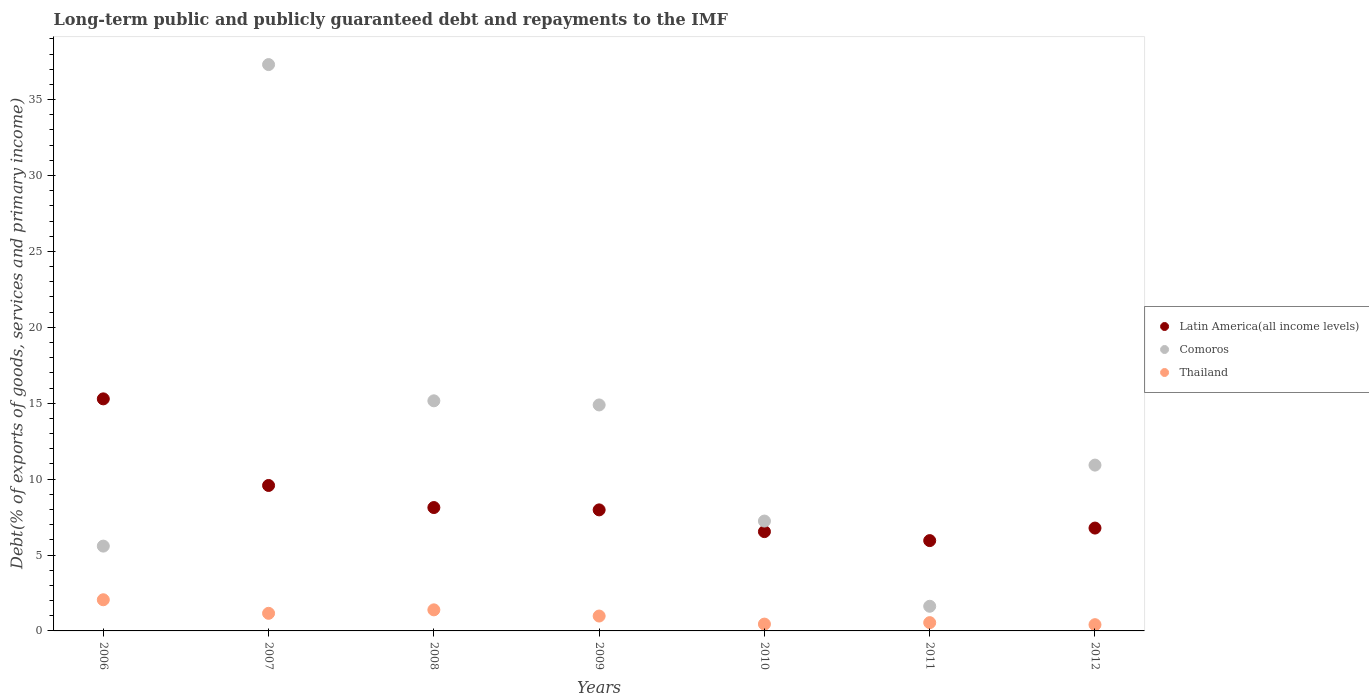How many different coloured dotlines are there?
Ensure brevity in your answer.  3. What is the debt and repayments in Thailand in 2012?
Offer a terse response. 0.41. Across all years, what is the maximum debt and repayments in Thailand?
Provide a short and direct response. 2.05. Across all years, what is the minimum debt and repayments in Thailand?
Your answer should be compact. 0.41. In which year was the debt and repayments in Latin America(all income levels) maximum?
Provide a succinct answer. 2006. What is the total debt and repayments in Comoros in the graph?
Provide a succinct answer. 92.73. What is the difference between the debt and repayments in Thailand in 2009 and that in 2010?
Provide a short and direct response. 0.53. What is the difference between the debt and repayments in Comoros in 2006 and the debt and repayments in Latin America(all income levels) in 2008?
Offer a terse response. -2.54. What is the average debt and repayments in Latin America(all income levels) per year?
Offer a terse response. 8.61. In the year 2009, what is the difference between the debt and repayments in Comoros and debt and repayments in Thailand?
Your answer should be compact. 13.91. What is the ratio of the debt and repayments in Comoros in 2006 to that in 2009?
Provide a short and direct response. 0.38. Is the debt and repayments in Comoros in 2010 less than that in 2011?
Your response must be concise. No. What is the difference between the highest and the second highest debt and repayments in Latin America(all income levels)?
Give a very brief answer. 5.71. What is the difference between the highest and the lowest debt and repayments in Comoros?
Keep it short and to the point. 35.68. In how many years, is the debt and repayments in Thailand greater than the average debt and repayments in Thailand taken over all years?
Keep it short and to the point. 3. Does the debt and repayments in Latin America(all income levels) monotonically increase over the years?
Make the answer very short. No. Is the debt and repayments in Comoros strictly less than the debt and repayments in Thailand over the years?
Provide a short and direct response. No. Does the graph contain any zero values?
Make the answer very short. No. Does the graph contain grids?
Your answer should be compact. No. How many legend labels are there?
Offer a terse response. 3. What is the title of the graph?
Your answer should be compact. Long-term public and publicly guaranteed debt and repayments to the IMF. Does "Other small states" appear as one of the legend labels in the graph?
Your response must be concise. No. What is the label or title of the Y-axis?
Keep it short and to the point. Debt(% of exports of goods, services and primary income). What is the Debt(% of exports of goods, services and primary income) in Latin America(all income levels) in 2006?
Give a very brief answer. 15.29. What is the Debt(% of exports of goods, services and primary income) of Comoros in 2006?
Keep it short and to the point. 5.59. What is the Debt(% of exports of goods, services and primary income) of Thailand in 2006?
Give a very brief answer. 2.05. What is the Debt(% of exports of goods, services and primary income) of Latin America(all income levels) in 2007?
Your answer should be very brief. 9.58. What is the Debt(% of exports of goods, services and primary income) of Comoros in 2007?
Offer a terse response. 37.31. What is the Debt(% of exports of goods, services and primary income) of Thailand in 2007?
Offer a terse response. 1.16. What is the Debt(% of exports of goods, services and primary income) in Latin America(all income levels) in 2008?
Your response must be concise. 8.13. What is the Debt(% of exports of goods, services and primary income) of Comoros in 2008?
Ensure brevity in your answer.  15.16. What is the Debt(% of exports of goods, services and primary income) of Thailand in 2008?
Provide a succinct answer. 1.39. What is the Debt(% of exports of goods, services and primary income) of Latin America(all income levels) in 2009?
Your answer should be very brief. 7.97. What is the Debt(% of exports of goods, services and primary income) of Comoros in 2009?
Keep it short and to the point. 14.89. What is the Debt(% of exports of goods, services and primary income) in Thailand in 2009?
Provide a short and direct response. 0.98. What is the Debt(% of exports of goods, services and primary income) of Latin America(all income levels) in 2010?
Your answer should be very brief. 6.54. What is the Debt(% of exports of goods, services and primary income) in Comoros in 2010?
Give a very brief answer. 7.24. What is the Debt(% of exports of goods, services and primary income) in Thailand in 2010?
Keep it short and to the point. 0.45. What is the Debt(% of exports of goods, services and primary income) in Latin America(all income levels) in 2011?
Your answer should be very brief. 5.95. What is the Debt(% of exports of goods, services and primary income) in Comoros in 2011?
Your response must be concise. 1.62. What is the Debt(% of exports of goods, services and primary income) of Thailand in 2011?
Your answer should be very brief. 0.55. What is the Debt(% of exports of goods, services and primary income) in Latin America(all income levels) in 2012?
Ensure brevity in your answer.  6.78. What is the Debt(% of exports of goods, services and primary income) in Comoros in 2012?
Keep it short and to the point. 10.92. What is the Debt(% of exports of goods, services and primary income) in Thailand in 2012?
Give a very brief answer. 0.41. Across all years, what is the maximum Debt(% of exports of goods, services and primary income) of Latin America(all income levels)?
Make the answer very short. 15.29. Across all years, what is the maximum Debt(% of exports of goods, services and primary income) of Comoros?
Provide a succinct answer. 37.31. Across all years, what is the maximum Debt(% of exports of goods, services and primary income) in Thailand?
Your answer should be compact. 2.05. Across all years, what is the minimum Debt(% of exports of goods, services and primary income) in Latin America(all income levels)?
Ensure brevity in your answer.  5.95. Across all years, what is the minimum Debt(% of exports of goods, services and primary income) of Comoros?
Your answer should be very brief. 1.62. Across all years, what is the minimum Debt(% of exports of goods, services and primary income) of Thailand?
Your answer should be very brief. 0.41. What is the total Debt(% of exports of goods, services and primary income) in Latin America(all income levels) in the graph?
Make the answer very short. 60.24. What is the total Debt(% of exports of goods, services and primary income) in Comoros in the graph?
Ensure brevity in your answer.  92.73. What is the total Debt(% of exports of goods, services and primary income) in Thailand in the graph?
Make the answer very short. 6.99. What is the difference between the Debt(% of exports of goods, services and primary income) in Latin America(all income levels) in 2006 and that in 2007?
Keep it short and to the point. 5.71. What is the difference between the Debt(% of exports of goods, services and primary income) of Comoros in 2006 and that in 2007?
Your response must be concise. -31.72. What is the difference between the Debt(% of exports of goods, services and primary income) in Thailand in 2006 and that in 2007?
Keep it short and to the point. 0.89. What is the difference between the Debt(% of exports of goods, services and primary income) of Latin America(all income levels) in 2006 and that in 2008?
Offer a terse response. 7.16. What is the difference between the Debt(% of exports of goods, services and primary income) of Comoros in 2006 and that in 2008?
Keep it short and to the point. -9.57. What is the difference between the Debt(% of exports of goods, services and primary income) of Thailand in 2006 and that in 2008?
Ensure brevity in your answer.  0.66. What is the difference between the Debt(% of exports of goods, services and primary income) of Latin America(all income levels) in 2006 and that in 2009?
Provide a short and direct response. 7.31. What is the difference between the Debt(% of exports of goods, services and primary income) of Comoros in 2006 and that in 2009?
Ensure brevity in your answer.  -9.3. What is the difference between the Debt(% of exports of goods, services and primary income) of Thailand in 2006 and that in 2009?
Your response must be concise. 1.07. What is the difference between the Debt(% of exports of goods, services and primary income) of Latin America(all income levels) in 2006 and that in 2010?
Give a very brief answer. 8.75. What is the difference between the Debt(% of exports of goods, services and primary income) of Comoros in 2006 and that in 2010?
Provide a short and direct response. -1.65. What is the difference between the Debt(% of exports of goods, services and primary income) in Thailand in 2006 and that in 2010?
Your response must be concise. 1.6. What is the difference between the Debt(% of exports of goods, services and primary income) of Latin America(all income levels) in 2006 and that in 2011?
Offer a very short reply. 9.34. What is the difference between the Debt(% of exports of goods, services and primary income) of Comoros in 2006 and that in 2011?
Give a very brief answer. 3.96. What is the difference between the Debt(% of exports of goods, services and primary income) of Thailand in 2006 and that in 2011?
Your response must be concise. 1.51. What is the difference between the Debt(% of exports of goods, services and primary income) in Latin America(all income levels) in 2006 and that in 2012?
Offer a very short reply. 8.51. What is the difference between the Debt(% of exports of goods, services and primary income) of Comoros in 2006 and that in 2012?
Your response must be concise. -5.34. What is the difference between the Debt(% of exports of goods, services and primary income) in Thailand in 2006 and that in 2012?
Provide a short and direct response. 1.64. What is the difference between the Debt(% of exports of goods, services and primary income) of Latin America(all income levels) in 2007 and that in 2008?
Your response must be concise. 1.45. What is the difference between the Debt(% of exports of goods, services and primary income) of Comoros in 2007 and that in 2008?
Your answer should be compact. 22.15. What is the difference between the Debt(% of exports of goods, services and primary income) of Thailand in 2007 and that in 2008?
Your answer should be very brief. -0.23. What is the difference between the Debt(% of exports of goods, services and primary income) in Latin America(all income levels) in 2007 and that in 2009?
Provide a short and direct response. 1.61. What is the difference between the Debt(% of exports of goods, services and primary income) in Comoros in 2007 and that in 2009?
Provide a short and direct response. 22.42. What is the difference between the Debt(% of exports of goods, services and primary income) in Thailand in 2007 and that in 2009?
Ensure brevity in your answer.  0.18. What is the difference between the Debt(% of exports of goods, services and primary income) of Latin America(all income levels) in 2007 and that in 2010?
Offer a very short reply. 3.04. What is the difference between the Debt(% of exports of goods, services and primary income) of Comoros in 2007 and that in 2010?
Make the answer very short. 30.07. What is the difference between the Debt(% of exports of goods, services and primary income) of Thailand in 2007 and that in 2010?
Your answer should be compact. 0.71. What is the difference between the Debt(% of exports of goods, services and primary income) of Latin America(all income levels) in 2007 and that in 2011?
Keep it short and to the point. 3.63. What is the difference between the Debt(% of exports of goods, services and primary income) of Comoros in 2007 and that in 2011?
Your answer should be very brief. 35.68. What is the difference between the Debt(% of exports of goods, services and primary income) of Thailand in 2007 and that in 2011?
Give a very brief answer. 0.61. What is the difference between the Debt(% of exports of goods, services and primary income) in Latin America(all income levels) in 2007 and that in 2012?
Provide a succinct answer. 2.81. What is the difference between the Debt(% of exports of goods, services and primary income) in Comoros in 2007 and that in 2012?
Give a very brief answer. 26.39. What is the difference between the Debt(% of exports of goods, services and primary income) of Thailand in 2007 and that in 2012?
Ensure brevity in your answer.  0.75. What is the difference between the Debt(% of exports of goods, services and primary income) in Latin America(all income levels) in 2008 and that in 2009?
Your answer should be very brief. 0.15. What is the difference between the Debt(% of exports of goods, services and primary income) in Comoros in 2008 and that in 2009?
Keep it short and to the point. 0.27. What is the difference between the Debt(% of exports of goods, services and primary income) in Thailand in 2008 and that in 2009?
Your response must be concise. 0.41. What is the difference between the Debt(% of exports of goods, services and primary income) of Latin America(all income levels) in 2008 and that in 2010?
Ensure brevity in your answer.  1.59. What is the difference between the Debt(% of exports of goods, services and primary income) in Comoros in 2008 and that in 2010?
Give a very brief answer. 7.92. What is the difference between the Debt(% of exports of goods, services and primary income) of Thailand in 2008 and that in 2010?
Offer a terse response. 0.94. What is the difference between the Debt(% of exports of goods, services and primary income) in Latin America(all income levels) in 2008 and that in 2011?
Offer a very short reply. 2.18. What is the difference between the Debt(% of exports of goods, services and primary income) in Comoros in 2008 and that in 2011?
Your response must be concise. 13.53. What is the difference between the Debt(% of exports of goods, services and primary income) of Thailand in 2008 and that in 2011?
Your answer should be compact. 0.84. What is the difference between the Debt(% of exports of goods, services and primary income) of Latin America(all income levels) in 2008 and that in 2012?
Your answer should be very brief. 1.35. What is the difference between the Debt(% of exports of goods, services and primary income) in Comoros in 2008 and that in 2012?
Your answer should be very brief. 4.24. What is the difference between the Debt(% of exports of goods, services and primary income) in Thailand in 2008 and that in 2012?
Give a very brief answer. 0.98. What is the difference between the Debt(% of exports of goods, services and primary income) in Latin America(all income levels) in 2009 and that in 2010?
Make the answer very short. 1.43. What is the difference between the Debt(% of exports of goods, services and primary income) of Comoros in 2009 and that in 2010?
Your response must be concise. 7.65. What is the difference between the Debt(% of exports of goods, services and primary income) in Thailand in 2009 and that in 2010?
Your response must be concise. 0.53. What is the difference between the Debt(% of exports of goods, services and primary income) of Latin America(all income levels) in 2009 and that in 2011?
Your response must be concise. 2.02. What is the difference between the Debt(% of exports of goods, services and primary income) of Comoros in 2009 and that in 2011?
Provide a succinct answer. 13.26. What is the difference between the Debt(% of exports of goods, services and primary income) of Thailand in 2009 and that in 2011?
Make the answer very short. 0.43. What is the difference between the Debt(% of exports of goods, services and primary income) in Latin America(all income levels) in 2009 and that in 2012?
Provide a short and direct response. 1.2. What is the difference between the Debt(% of exports of goods, services and primary income) in Comoros in 2009 and that in 2012?
Offer a terse response. 3.96. What is the difference between the Debt(% of exports of goods, services and primary income) of Thailand in 2009 and that in 2012?
Your answer should be very brief. 0.57. What is the difference between the Debt(% of exports of goods, services and primary income) in Latin America(all income levels) in 2010 and that in 2011?
Provide a succinct answer. 0.59. What is the difference between the Debt(% of exports of goods, services and primary income) of Comoros in 2010 and that in 2011?
Offer a very short reply. 5.61. What is the difference between the Debt(% of exports of goods, services and primary income) in Thailand in 2010 and that in 2011?
Your answer should be compact. -0.1. What is the difference between the Debt(% of exports of goods, services and primary income) of Latin America(all income levels) in 2010 and that in 2012?
Make the answer very short. -0.23. What is the difference between the Debt(% of exports of goods, services and primary income) in Comoros in 2010 and that in 2012?
Provide a succinct answer. -3.69. What is the difference between the Debt(% of exports of goods, services and primary income) of Thailand in 2010 and that in 2012?
Your answer should be compact. 0.04. What is the difference between the Debt(% of exports of goods, services and primary income) in Latin America(all income levels) in 2011 and that in 2012?
Your answer should be very brief. -0.83. What is the difference between the Debt(% of exports of goods, services and primary income) in Comoros in 2011 and that in 2012?
Your response must be concise. -9.3. What is the difference between the Debt(% of exports of goods, services and primary income) of Thailand in 2011 and that in 2012?
Provide a succinct answer. 0.13. What is the difference between the Debt(% of exports of goods, services and primary income) of Latin America(all income levels) in 2006 and the Debt(% of exports of goods, services and primary income) of Comoros in 2007?
Your answer should be compact. -22.02. What is the difference between the Debt(% of exports of goods, services and primary income) of Latin America(all income levels) in 2006 and the Debt(% of exports of goods, services and primary income) of Thailand in 2007?
Offer a very short reply. 14.13. What is the difference between the Debt(% of exports of goods, services and primary income) of Comoros in 2006 and the Debt(% of exports of goods, services and primary income) of Thailand in 2007?
Offer a terse response. 4.43. What is the difference between the Debt(% of exports of goods, services and primary income) in Latin America(all income levels) in 2006 and the Debt(% of exports of goods, services and primary income) in Comoros in 2008?
Your answer should be very brief. 0.13. What is the difference between the Debt(% of exports of goods, services and primary income) in Latin America(all income levels) in 2006 and the Debt(% of exports of goods, services and primary income) in Thailand in 2008?
Give a very brief answer. 13.9. What is the difference between the Debt(% of exports of goods, services and primary income) of Comoros in 2006 and the Debt(% of exports of goods, services and primary income) of Thailand in 2008?
Ensure brevity in your answer.  4.2. What is the difference between the Debt(% of exports of goods, services and primary income) of Latin America(all income levels) in 2006 and the Debt(% of exports of goods, services and primary income) of Comoros in 2009?
Provide a succinct answer. 0.4. What is the difference between the Debt(% of exports of goods, services and primary income) in Latin America(all income levels) in 2006 and the Debt(% of exports of goods, services and primary income) in Thailand in 2009?
Make the answer very short. 14.31. What is the difference between the Debt(% of exports of goods, services and primary income) of Comoros in 2006 and the Debt(% of exports of goods, services and primary income) of Thailand in 2009?
Your response must be concise. 4.61. What is the difference between the Debt(% of exports of goods, services and primary income) of Latin America(all income levels) in 2006 and the Debt(% of exports of goods, services and primary income) of Comoros in 2010?
Keep it short and to the point. 8.05. What is the difference between the Debt(% of exports of goods, services and primary income) of Latin America(all income levels) in 2006 and the Debt(% of exports of goods, services and primary income) of Thailand in 2010?
Give a very brief answer. 14.84. What is the difference between the Debt(% of exports of goods, services and primary income) of Comoros in 2006 and the Debt(% of exports of goods, services and primary income) of Thailand in 2010?
Provide a succinct answer. 5.14. What is the difference between the Debt(% of exports of goods, services and primary income) of Latin America(all income levels) in 2006 and the Debt(% of exports of goods, services and primary income) of Comoros in 2011?
Provide a short and direct response. 13.66. What is the difference between the Debt(% of exports of goods, services and primary income) of Latin America(all income levels) in 2006 and the Debt(% of exports of goods, services and primary income) of Thailand in 2011?
Give a very brief answer. 14.74. What is the difference between the Debt(% of exports of goods, services and primary income) of Comoros in 2006 and the Debt(% of exports of goods, services and primary income) of Thailand in 2011?
Your answer should be very brief. 5.04. What is the difference between the Debt(% of exports of goods, services and primary income) of Latin America(all income levels) in 2006 and the Debt(% of exports of goods, services and primary income) of Comoros in 2012?
Your answer should be compact. 4.36. What is the difference between the Debt(% of exports of goods, services and primary income) of Latin America(all income levels) in 2006 and the Debt(% of exports of goods, services and primary income) of Thailand in 2012?
Keep it short and to the point. 14.88. What is the difference between the Debt(% of exports of goods, services and primary income) in Comoros in 2006 and the Debt(% of exports of goods, services and primary income) in Thailand in 2012?
Make the answer very short. 5.18. What is the difference between the Debt(% of exports of goods, services and primary income) of Latin America(all income levels) in 2007 and the Debt(% of exports of goods, services and primary income) of Comoros in 2008?
Provide a short and direct response. -5.58. What is the difference between the Debt(% of exports of goods, services and primary income) in Latin America(all income levels) in 2007 and the Debt(% of exports of goods, services and primary income) in Thailand in 2008?
Your answer should be compact. 8.19. What is the difference between the Debt(% of exports of goods, services and primary income) in Comoros in 2007 and the Debt(% of exports of goods, services and primary income) in Thailand in 2008?
Provide a succinct answer. 35.92. What is the difference between the Debt(% of exports of goods, services and primary income) in Latin America(all income levels) in 2007 and the Debt(% of exports of goods, services and primary income) in Comoros in 2009?
Offer a very short reply. -5.3. What is the difference between the Debt(% of exports of goods, services and primary income) in Latin America(all income levels) in 2007 and the Debt(% of exports of goods, services and primary income) in Thailand in 2009?
Offer a very short reply. 8.6. What is the difference between the Debt(% of exports of goods, services and primary income) of Comoros in 2007 and the Debt(% of exports of goods, services and primary income) of Thailand in 2009?
Your answer should be very brief. 36.33. What is the difference between the Debt(% of exports of goods, services and primary income) in Latin America(all income levels) in 2007 and the Debt(% of exports of goods, services and primary income) in Comoros in 2010?
Your response must be concise. 2.34. What is the difference between the Debt(% of exports of goods, services and primary income) of Latin America(all income levels) in 2007 and the Debt(% of exports of goods, services and primary income) of Thailand in 2010?
Your response must be concise. 9.13. What is the difference between the Debt(% of exports of goods, services and primary income) in Comoros in 2007 and the Debt(% of exports of goods, services and primary income) in Thailand in 2010?
Your answer should be compact. 36.86. What is the difference between the Debt(% of exports of goods, services and primary income) of Latin America(all income levels) in 2007 and the Debt(% of exports of goods, services and primary income) of Comoros in 2011?
Give a very brief answer. 7.96. What is the difference between the Debt(% of exports of goods, services and primary income) in Latin America(all income levels) in 2007 and the Debt(% of exports of goods, services and primary income) in Thailand in 2011?
Make the answer very short. 9.04. What is the difference between the Debt(% of exports of goods, services and primary income) of Comoros in 2007 and the Debt(% of exports of goods, services and primary income) of Thailand in 2011?
Give a very brief answer. 36.76. What is the difference between the Debt(% of exports of goods, services and primary income) of Latin America(all income levels) in 2007 and the Debt(% of exports of goods, services and primary income) of Comoros in 2012?
Offer a terse response. -1.34. What is the difference between the Debt(% of exports of goods, services and primary income) in Latin America(all income levels) in 2007 and the Debt(% of exports of goods, services and primary income) in Thailand in 2012?
Make the answer very short. 9.17. What is the difference between the Debt(% of exports of goods, services and primary income) in Comoros in 2007 and the Debt(% of exports of goods, services and primary income) in Thailand in 2012?
Offer a very short reply. 36.9. What is the difference between the Debt(% of exports of goods, services and primary income) in Latin America(all income levels) in 2008 and the Debt(% of exports of goods, services and primary income) in Comoros in 2009?
Provide a short and direct response. -6.76. What is the difference between the Debt(% of exports of goods, services and primary income) in Latin America(all income levels) in 2008 and the Debt(% of exports of goods, services and primary income) in Thailand in 2009?
Provide a short and direct response. 7.15. What is the difference between the Debt(% of exports of goods, services and primary income) of Comoros in 2008 and the Debt(% of exports of goods, services and primary income) of Thailand in 2009?
Make the answer very short. 14.18. What is the difference between the Debt(% of exports of goods, services and primary income) of Latin America(all income levels) in 2008 and the Debt(% of exports of goods, services and primary income) of Comoros in 2010?
Offer a terse response. 0.89. What is the difference between the Debt(% of exports of goods, services and primary income) of Latin America(all income levels) in 2008 and the Debt(% of exports of goods, services and primary income) of Thailand in 2010?
Your response must be concise. 7.68. What is the difference between the Debt(% of exports of goods, services and primary income) in Comoros in 2008 and the Debt(% of exports of goods, services and primary income) in Thailand in 2010?
Your response must be concise. 14.71. What is the difference between the Debt(% of exports of goods, services and primary income) of Latin America(all income levels) in 2008 and the Debt(% of exports of goods, services and primary income) of Comoros in 2011?
Ensure brevity in your answer.  6.5. What is the difference between the Debt(% of exports of goods, services and primary income) of Latin America(all income levels) in 2008 and the Debt(% of exports of goods, services and primary income) of Thailand in 2011?
Your answer should be compact. 7.58. What is the difference between the Debt(% of exports of goods, services and primary income) in Comoros in 2008 and the Debt(% of exports of goods, services and primary income) in Thailand in 2011?
Your answer should be very brief. 14.61. What is the difference between the Debt(% of exports of goods, services and primary income) in Latin America(all income levels) in 2008 and the Debt(% of exports of goods, services and primary income) in Comoros in 2012?
Make the answer very short. -2.8. What is the difference between the Debt(% of exports of goods, services and primary income) of Latin America(all income levels) in 2008 and the Debt(% of exports of goods, services and primary income) of Thailand in 2012?
Your answer should be compact. 7.72. What is the difference between the Debt(% of exports of goods, services and primary income) of Comoros in 2008 and the Debt(% of exports of goods, services and primary income) of Thailand in 2012?
Provide a short and direct response. 14.75. What is the difference between the Debt(% of exports of goods, services and primary income) of Latin America(all income levels) in 2009 and the Debt(% of exports of goods, services and primary income) of Comoros in 2010?
Offer a very short reply. 0.74. What is the difference between the Debt(% of exports of goods, services and primary income) in Latin America(all income levels) in 2009 and the Debt(% of exports of goods, services and primary income) in Thailand in 2010?
Provide a succinct answer. 7.52. What is the difference between the Debt(% of exports of goods, services and primary income) of Comoros in 2009 and the Debt(% of exports of goods, services and primary income) of Thailand in 2010?
Keep it short and to the point. 14.44. What is the difference between the Debt(% of exports of goods, services and primary income) in Latin America(all income levels) in 2009 and the Debt(% of exports of goods, services and primary income) in Comoros in 2011?
Ensure brevity in your answer.  6.35. What is the difference between the Debt(% of exports of goods, services and primary income) of Latin America(all income levels) in 2009 and the Debt(% of exports of goods, services and primary income) of Thailand in 2011?
Provide a succinct answer. 7.43. What is the difference between the Debt(% of exports of goods, services and primary income) in Comoros in 2009 and the Debt(% of exports of goods, services and primary income) in Thailand in 2011?
Offer a very short reply. 14.34. What is the difference between the Debt(% of exports of goods, services and primary income) in Latin America(all income levels) in 2009 and the Debt(% of exports of goods, services and primary income) in Comoros in 2012?
Make the answer very short. -2.95. What is the difference between the Debt(% of exports of goods, services and primary income) of Latin America(all income levels) in 2009 and the Debt(% of exports of goods, services and primary income) of Thailand in 2012?
Offer a terse response. 7.56. What is the difference between the Debt(% of exports of goods, services and primary income) in Comoros in 2009 and the Debt(% of exports of goods, services and primary income) in Thailand in 2012?
Your response must be concise. 14.48. What is the difference between the Debt(% of exports of goods, services and primary income) of Latin America(all income levels) in 2010 and the Debt(% of exports of goods, services and primary income) of Comoros in 2011?
Keep it short and to the point. 4.92. What is the difference between the Debt(% of exports of goods, services and primary income) in Latin America(all income levels) in 2010 and the Debt(% of exports of goods, services and primary income) in Thailand in 2011?
Your answer should be very brief. 6. What is the difference between the Debt(% of exports of goods, services and primary income) in Comoros in 2010 and the Debt(% of exports of goods, services and primary income) in Thailand in 2011?
Offer a very short reply. 6.69. What is the difference between the Debt(% of exports of goods, services and primary income) in Latin America(all income levels) in 2010 and the Debt(% of exports of goods, services and primary income) in Comoros in 2012?
Ensure brevity in your answer.  -4.38. What is the difference between the Debt(% of exports of goods, services and primary income) in Latin America(all income levels) in 2010 and the Debt(% of exports of goods, services and primary income) in Thailand in 2012?
Your response must be concise. 6.13. What is the difference between the Debt(% of exports of goods, services and primary income) in Comoros in 2010 and the Debt(% of exports of goods, services and primary income) in Thailand in 2012?
Provide a succinct answer. 6.83. What is the difference between the Debt(% of exports of goods, services and primary income) of Latin America(all income levels) in 2011 and the Debt(% of exports of goods, services and primary income) of Comoros in 2012?
Give a very brief answer. -4.97. What is the difference between the Debt(% of exports of goods, services and primary income) in Latin America(all income levels) in 2011 and the Debt(% of exports of goods, services and primary income) in Thailand in 2012?
Provide a short and direct response. 5.54. What is the difference between the Debt(% of exports of goods, services and primary income) of Comoros in 2011 and the Debt(% of exports of goods, services and primary income) of Thailand in 2012?
Give a very brief answer. 1.21. What is the average Debt(% of exports of goods, services and primary income) in Latin America(all income levels) per year?
Provide a short and direct response. 8.61. What is the average Debt(% of exports of goods, services and primary income) in Comoros per year?
Ensure brevity in your answer.  13.25. What is the average Debt(% of exports of goods, services and primary income) in Thailand per year?
Provide a succinct answer. 1. In the year 2006, what is the difference between the Debt(% of exports of goods, services and primary income) in Latin America(all income levels) and Debt(% of exports of goods, services and primary income) in Comoros?
Your response must be concise. 9.7. In the year 2006, what is the difference between the Debt(% of exports of goods, services and primary income) of Latin America(all income levels) and Debt(% of exports of goods, services and primary income) of Thailand?
Keep it short and to the point. 13.23. In the year 2006, what is the difference between the Debt(% of exports of goods, services and primary income) in Comoros and Debt(% of exports of goods, services and primary income) in Thailand?
Your answer should be very brief. 3.53. In the year 2007, what is the difference between the Debt(% of exports of goods, services and primary income) of Latin America(all income levels) and Debt(% of exports of goods, services and primary income) of Comoros?
Offer a terse response. -27.73. In the year 2007, what is the difference between the Debt(% of exports of goods, services and primary income) of Latin America(all income levels) and Debt(% of exports of goods, services and primary income) of Thailand?
Offer a terse response. 8.42. In the year 2007, what is the difference between the Debt(% of exports of goods, services and primary income) of Comoros and Debt(% of exports of goods, services and primary income) of Thailand?
Provide a short and direct response. 36.15. In the year 2008, what is the difference between the Debt(% of exports of goods, services and primary income) of Latin America(all income levels) and Debt(% of exports of goods, services and primary income) of Comoros?
Provide a succinct answer. -7.03. In the year 2008, what is the difference between the Debt(% of exports of goods, services and primary income) in Latin America(all income levels) and Debt(% of exports of goods, services and primary income) in Thailand?
Ensure brevity in your answer.  6.74. In the year 2008, what is the difference between the Debt(% of exports of goods, services and primary income) in Comoros and Debt(% of exports of goods, services and primary income) in Thailand?
Your answer should be very brief. 13.77. In the year 2009, what is the difference between the Debt(% of exports of goods, services and primary income) in Latin America(all income levels) and Debt(% of exports of goods, services and primary income) in Comoros?
Ensure brevity in your answer.  -6.91. In the year 2009, what is the difference between the Debt(% of exports of goods, services and primary income) in Latin America(all income levels) and Debt(% of exports of goods, services and primary income) in Thailand?
Provide a short and direct response. 6.99. In the year 2009, what is the difference between the Debt(% of exports of goods, services and primary income) of Comoros and Debt(% of exports of goods, services and primary income) of Thailand?
Offer a terse response. 13.91. In the year 2010, what is the difference between the Debt(% of exports of goods, services and primary income) of Latin America(all income levels) and Debt(% of exports of goods, services and primary income) of Comoros?
Provide a succinct answer. -0.7. In the year 2010, what is the difference between the Debt(% of exports of goods, services and primary income) in Latin America(all income levels) and Debt(% of exports of goods, services and primary income) in Thailand?
Offer a very short reply. 6.09. In the year 2010, what is the difference between the Debt(% of exports of goods, services and primary income) of Comoros and Debt(% of exports of goods, services and primary income) of Thailand?
Provide a short and direct response. 6.79. In the year 2011, what is the difference between the Debt(% of exports of goods, services and primary income) in Latin America(all income levels) and Debt(% of exports of goods, services and primary income) in Comoros?
Give a very brief answer. 4.33. In the year 2011, what is the difference between the Debt(% of exports of goods, services and primary income) in Latin America(all income levels) and Debt(% of exports of goods, services and primary income) in Thailand?
Your answer should be compact. 5.4. In the year 2011, what is the difference between the Debt(% of exports of goods, services and primary income) of Comoros and Debt(% of exports of goods, services and primary income) of Thailand?
Your answer should be very brief. 1.08. In the year 2012, what is the difference between the Debt(% of exports of goods, services and primary income) in Latin America(all income levels) and Debt(% of exports of goods, services and primary income) in Comoros?
Your answer should be very brief. -4.15. In the year 2012, what is the difference between the Debt(% of exports of goods, services and primary income) in Latin America(all income levels) and Debt(% of exports of goods, services and primary income) in Thailand?
Your answer should be very brief. 6.36. In the year 2012, what is the difference between the Debt(% of exports of goods, services and primary income) of Comoros and Debt(% of exports of goods, services and primary income) of Thailand?
Provide a succinct answer. 10.51. What is the ratio of the Debt(% of exports of goods, services and primary income) of Latin America(all income levels) in 2006 to that in 2007?
Keep it short and to the point. 1.6. What is the ratio of the Debt(% of exports of goods, services and primary income) in Comoros in 2006 to that in 2007?
Your answer should be very brief. 0.15. What is the ratio of the Debt(% of exports of goods, services and primary income) of Thailand in 2006 to that in 2007?
Your response must be concise. 1.77. What is the ratio of the Debt(% of exports of goods, services and primary income) of Latin America(all income levels) in 2006 to that in 2008?
Your response must be concise. 1.88. What is the ratio of the Debt(% of exports of goods, services and primary income) of Comoros in 2006 to that in 2008?
Offer a very short reply. 0.37. What is the ratio of the Debt(% of exports of goods, services and primary income) of Thailand in 2006 to that in 2008?
Your answer should be very brief. 1.48. What is the ratio of the Debt(% of exports of goods, services and primary income) in Latin America(all income levels) in 2006 to that in 2009?
Your answer should be very brief. 1.92. What is the ratio of the Debt(% of exports of goods, services and primary income) in Comoros in 2006 to that in 2009?
Ensure brevity in your answer.  0.38. What is the ratio of the Debt(% of exports of goods, services and primary income) of Thailand in 2006 to that in 2009?
Your response must be concise. 2.09. What is the ratio of the Debt(% of exports of goods, services and primary income) in Latin America(all income levels) in 2006 to that in 2010?
Give a very brief answer. 2.34. What is the ratio of the Debt(% of exports of goods, services and primary income) of Comoros in 2006 to that in 2010?
Your answer should be compact. 0.77. What is the ratio of the Debt(% of exports of goods, services and primary income) of Thailand in 2006 to that in 2010?
Your response must be concise. 4.57. What is the ratio of the Debt(% of exports of goods, services and primary income) in Latin America(all income levels) in 2006 to that in 2011?
Your answer should be very brief. 2.57. What is the ratio of the Debt(% of exports of goods, services and primary income) in Comoros in 2006 to that in 2011?
Your response must be concise. 3.44. What is the ratio of the Debt(% of exports of goods, services and primary income) of Thailand in 2006 to that in 2011?
Offer a very short reply. 3.76. What is the ratio of the Debt(% of exports of goods, services and primary income) of Latin America(all income levels) in 2006 to that in 2012?
Your response must be concise. 2.26. What is the ratio of the Debt(% of exports of goods, services and primary income) of Comoros in 2006 to that in 2012?
Your response must be concise. 0.51. What is the ratio of the Debt(% of exports of goods, services and primary income) of Thailand in 2006 to that in 2012?
Your response must be concise. 4.99. What is the ratio of the Debt(% of exports of goods, services and primary income) in Latin America(all income levels) in 2007 to that in 2008?
Ensure brevity in your answer.  1.18. What is the ratio of the Debt(% of exports of goods, services and primary income) in Comoros in 2007 to that in 2008?
Offer a very short reply. 2.46. What is the ratio of the Debt(% of exports of goods, services and primary income) of Thailand in 2007 to that in 2008?
Your response must be concise. 0.84. What is the ratio of the Debt(% of exports of goods, services and primary income) in Latin America(all income levels) in 2007 to that in 2009?
Offer a very short reply. 1.2. What is the ratio of the Debt(% of exports of goods, services and primary income) in Comoros in 2007 to that in 2009?
Make the answer very short. 2.51. What is the ratio of the Debt(% of exports of goods, services and primary income) of Thailand in 2007 to that in 2009?
Offer a terse response. 1.18. What is the ratio of the Debt(% of exports of goods, services and primary income) of Latin America(all income levels) in 2007 to that in 2010?
Provide a short and direct response. 1.46. What is the ratio of the Debt(% of exports of goods, services and primary income) of Comoros in 2007 to that in 2010?
Offer a terse response. 5.16. What is the ratio of the Debt(% of exports of goods, services and primary income) in Thailand in 2007 to that in 2010?
Offer a terse response. 2.58. What is the ratio of the Debt(% of exports of goods, services and primary income) of Latin America(all income levels) in 2007 to that in 2011?
Give a very brief answer. 1.61. What is the ratio of the Debt(% of exports of goods, services and primary income) in Comoros in 2007 to that in 2011?
Give a very brief answer. 22.97. What is the ratio of the Debt(% of exports of goods, services and primary income) in Thailand in 2007 to that in 2011?
Your answer should be very brief. 2.12. What is the ratio of the Debt(% of exports of goods, services and primary income) of Latin America(all income levels) in 2007 to that in 2012?
Provide a succinct answer. 1.41. What is the ratio of the Debt(% of exports of goods, services and primary income) of Comoros in 2007 to that in 2012?
Provide a succinct answer. 3.42. What is the ratio of the Debt(% of exports of goods, services and primary income) in Thailand in 2007 to that in 2012?
Your answer should be very brief. 2.82. What is the ratio of the Debt(% of exports of goods, services and primary income) in Latin America(all income levels) in 2008 to that in 2009?
Ensure brevity in your answer.  1.02. What is the ratio of the Debt(% of exports of goods, services and primary income) of Comoros in 2008 to that in 2009?
Provide a short and direct response. 1.02. What is the ratio of the Debt(% of exports of goods, services and primary income) of Thailand in 2008 to that in 2009?
Your answer should be compact. 1.42. What is the ratio of the Debt(% of exports of goods, services and primary income) of Latin America(all income levels) in 2008 to that in 2010?
Offer a very short reply. 1.24. What is the ratio of the Debt(% of exports of goods, services and primary income) in Comoros in 2008 to that in 2010?
Your answer should be very brief. 2.09. What is the ratio of the Debt(% of exports of goods, services and primary income) in Thailand in 2008 to that in 2010?
Your answer should be very brief. 3.09. What is the ratio of the Debt(% of exports of goods, services and primary income) in Latin America(all income levels) in 2008 to that in 2011?
Offer a very short reply. 1.37. What is the ratio of the Debt(% of exports of goods, services and primary income) in Comoros in 2008 to that in 2011?
Keep it short and to the point. 9.33. What is the ratio of the Debt(% of exports of goods, services and primary income) of Thailand in 2008 to that in 2011?
Give a very brief answer. 2.54. What is the ratio of the Debt(% of exports of goods, services and primary income) of Latin America(all income levels) in 2008 to that in 2012?
Provide a short and direct response. 1.2. What is the ratio of the Debt(% of exports of goods, services and primary income) in Comoros in 2008 to that in 2012?
Keep it short and to the point. 1.39. What is the ratio of the Debt(% of exports of goods, services and primary income) of Thailand in 2008 to that in 2012?
Your answer should be compact. 3.37. What is the ratio of the Debt(% of exports of goods, services and primary income) of Latin America(all income levels) in 2009 to that in 2010?
Provide a succinct answer. 1.22. What is the ratio of the Debt(% of exports of goods, services and primary income) of Comoros in 2009 to that in 2010?
Your answer should be very brief. 2.06. What is the ratio of the Debt(% of exports of goods, services and primary income) of Thailand in 2009 to that in 2010?
Ensure brevity in your answer.  2.18. What is the ratio of the Debt(% of exports of goods, services and primary income) in Latin America(all income levels) in 2009 to that in 2011?
Make the answer very short. 1.34. What is the ratio of the Debt(% of exports of goods, services and primary income) in Comoros in 2009 to that in 2011?
Provide a short and direct response. 9.16. What is the ratio of the Debt(% of exports of goods, services and primary income) of Thailand in 2009 to that in 2011?
Make the answer very short. 1.8. What is the ratio of the Debt(% of exports of goods, services and primary income) of Latin America(all income levels) in 2009 to that in 2012?
Keep it short and to the point. 1.18. What is the ratio of the Debt(% of exports of goods, services and primary income) in Comoros in 2009 to that in 2012?
Your response must be concise. 1.36. What is the ratio of the Debt(% of exports of goods, services and primary income) of Thailand in 2009 to that in 2012?
Keep it short and to the point. 2.38. What is the ratio of the Debt(% of exports of goods, services and primary income) of Latin America(all income levels) in 2010 to that in 2011?
Keep it short and to the point. 1.1. What is the ratio of the Debt(% of exports of goods, services and primary income) of Comoros in 2010 to that in 2011?
Your answer should be very brief. 4.46. What is the ratio of the Debt(% of exports of goods, services and primary income) of Thailand in 2010 to that in 2011?
Offer a very short reply. 0.82. What is the ratio of the Debt(% of exports of goods, services and primary income) in Latin America(all income levels) in 2010 to that in 2012?
Provide a succinct answer. 0.97. What is the ratio of the Debt(% of exports of goods, services and primary income) of Comoros in 2010 to that in 2012?
Provide a short and direct response. 0.66. What is the ratio of the Debt(% of exports of goods, services and primary income) in Thailand in 2010 to that in 2012?
Your response must be concise. 1.09. What is the ratio of the Debt(% of exports of goods, services and primary income) of Latin America(all income levels) in 2011 to that in 2012?
Your answer should be very brief. 0.88. What is the ratio of the Debt(% of exports of goods, services and primary income) in Comoros in 2011 to that in 2012?
Offer a terse response. 0.15. What is the ratio of the Debt(% of exports of goods, services and primary income) of Thailand in 2011 to that in 2012?
Keep it short and to the point. 1.33. What is the difference between the highest and the second highest Debt(% of exports of goods, services and primary income) of Latin America(all income levels)?
Keep it short and to the point. 5.71. What is the difference between the highest and the second highest Debt(% of exports of goods, services and primary income) in Comoros?
Give a very brief answer. 22.15. What is the difference between the highest and the second highest Debt(% of exports of goods, services and primary income) of Thailand?
Ensure brevity in your answer.  0.66. What is the difference between the highest and the lowest Debt(% of exports of goods, services and primary income) of Latin America(all income levels)?
Your response must be concise. 9.34. What is the difference between the highest and the lowest Debt(% of exports of goods, services and primary income) in Comoros?
Make the answer very short. 35.68. What is the difference between the highest and the lowest Debt(% of exports of goods, services and primary income) of Thailand?
Offer a terse response. 1.64. 